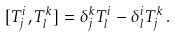<formula> <loc_0><loc_0><loc_500><loc_500>[ T _ { j } ^ { i } , T _ { l } ^ { k } ] = \delta _ { j } ^ { k } T _ { l } ^ { i } - \delta _ { l } ^ { i } T _ { j } ^ { k } \, .</formula> 